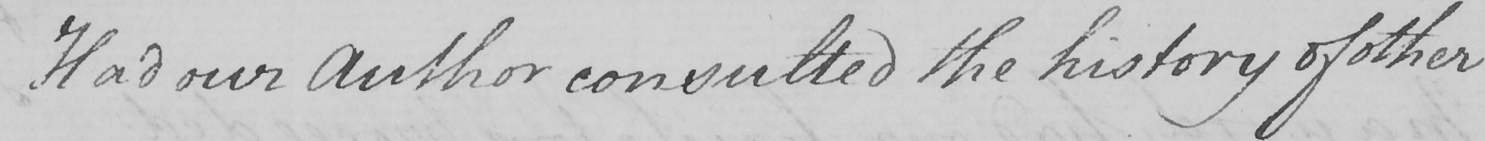Can you read and transcribe this handwriting? Had our Author consulted the history of other 